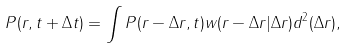<formula> <loc_0><loc_0><loc_500><loc_500>P ( { r } , t + \Delta t ) = \int P ( { r } - \Delta { r } , t ) w ( { r } - \Delta { r } | \Delta { r } ) d ^ { 2 } ( \Delta { r } ) ,</formula> 